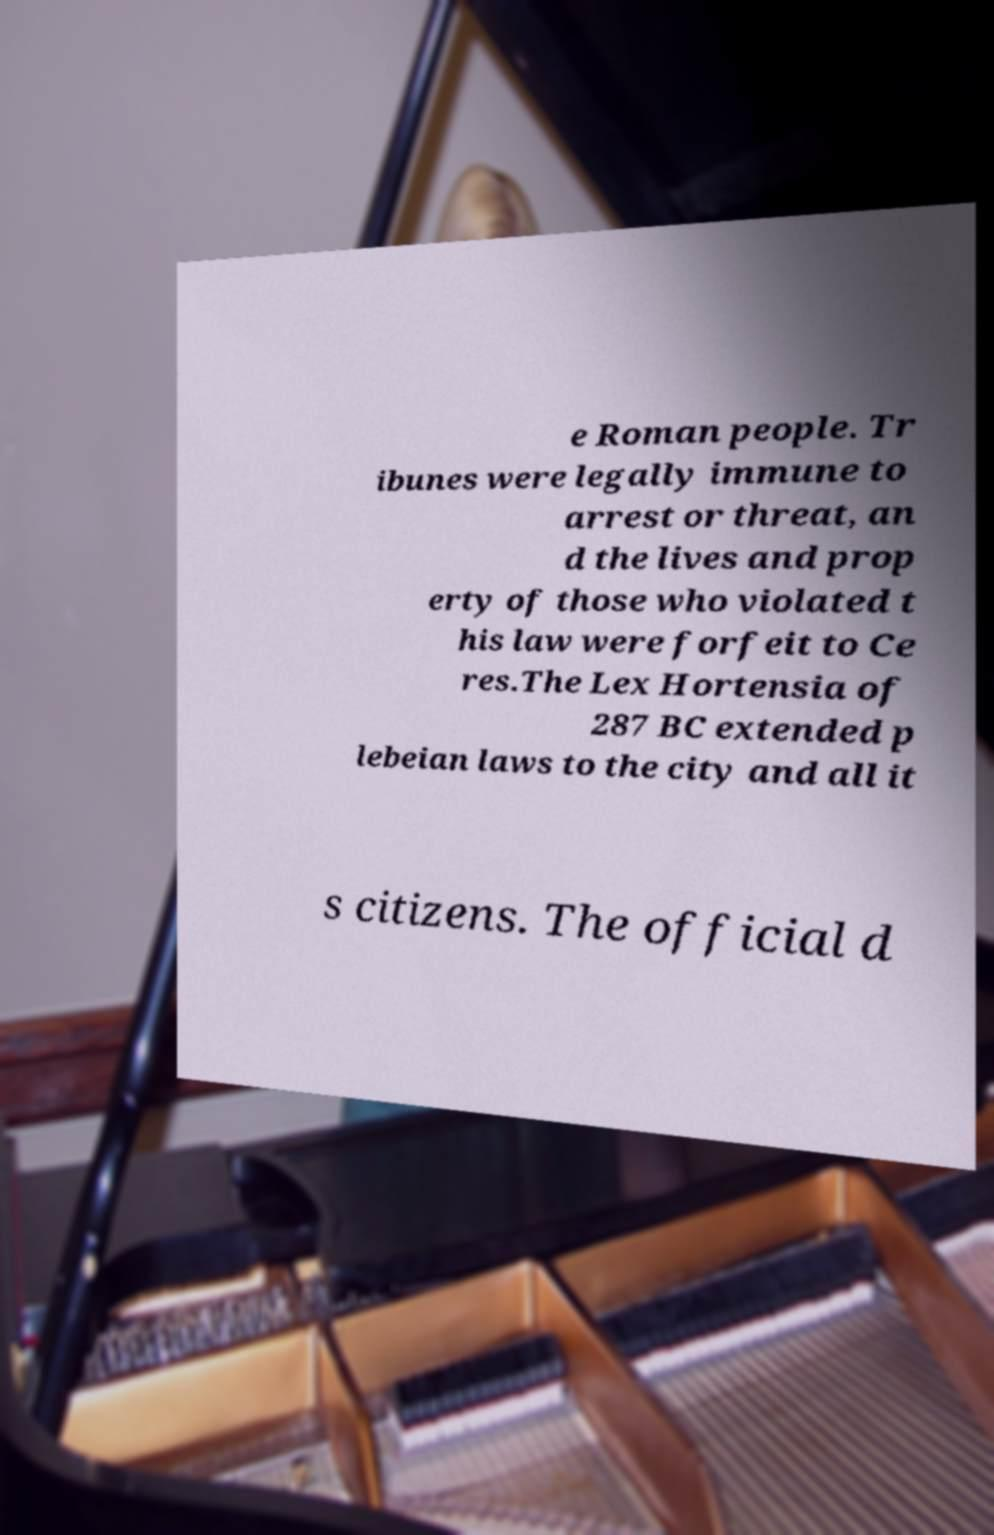Could you assist in decoding the text presented in this image and type it out clearly? e Roman people. Tr ibunes were legally immune to arrest or threat, an d the lives and prop erty of those who violated t his law were forfeit to Ce res.The Lex Hortensia of 287 BC extended p lebeian laws to the city and all it s citizens. The official d 